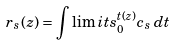Convert formula to latex. <formula><loc_0><loc_0><loc_500><loc_500>r _ { s } ( z ) = \int \lim i t s _ { 0 } ^ { t ( z ) } c _ { s } \, d t</formula> 